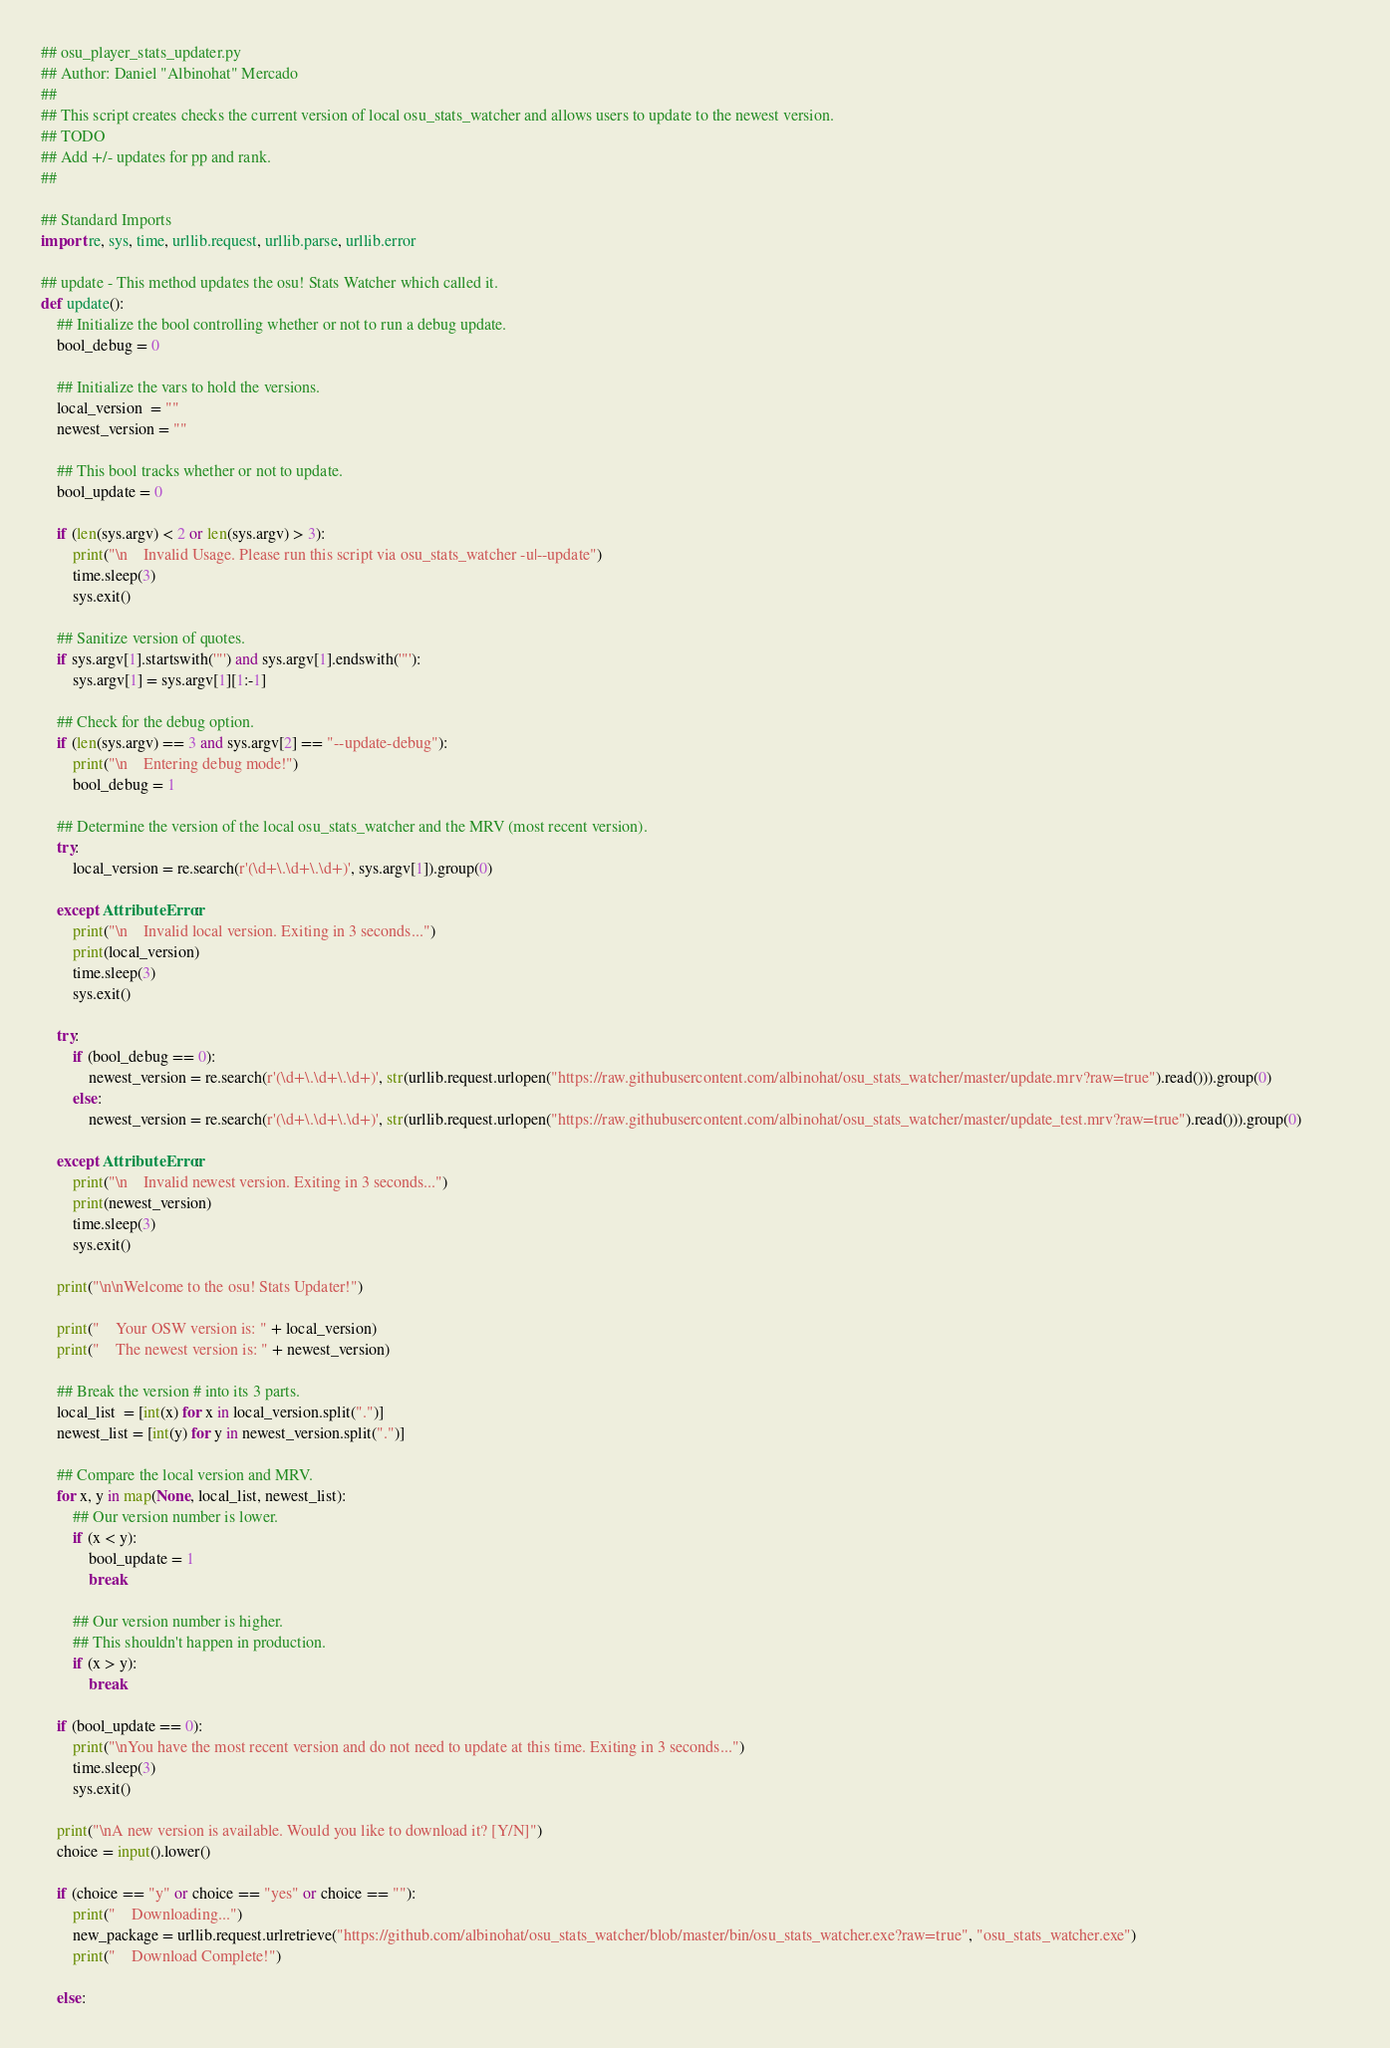<code> <loc_0><loc_0><loc_500><loc_500><_Python_>## osu_player_stats_updater.py
## Author: Daniel "Albinohat" Mercado
## 
## This script creates checks the current version of local osu_stats_watcher and allows users to update to the newest version.
## TODO
## Add +/- updates for pp and rank.
## 

## Standard Imports
import re, sys, time, urllib.request, urllib.parse, urllib.error

## update - This method updates the osu! Stats Watcher which called it.
def update():
	## Initialize the bool controlling whether or not to run a debug update.
	bool_debug = 0

	## Initialize the vars to hold the versions.
	local_version  = ""
	newest_version = ""

	## This bool tracks whether or not to update.
	bool_update = 0

	if (len(sys.argv) < 2 or len(sys.argv) > 3):
		print("\n    Invalid Usage. Please run this script via osu_stats_watcher -u|--update")
		time.sleep(3)
		sys.exit()

	## Sanitize version of quotes.
	if sys.argv[1].startswith('"') and sys.argv[1].endswith('"'):
		sys.argv[1] = sys.argv[1][1:-1]
	
	## Check for the debug option.
	if (len(sys.argv) == 3 and sys.argv[2] == "--update-debug"):
		print("\n    Entering debug mode!")
		bool_debug = 1
	
	## Determine the version of the local osu_stats_watcher and the MRV (most recent version).
	try:
		local_version = re.search(r'(\d+\.\d+\.\d+)', sys.argv[1]).group(0)

	except AttributeError:
		print("\n    Invalid local version. Exiting in 3 seconds...")
		print(local_version)
		time.sleep(3)		
		sys.exit()

	try:
		if (bool_debug == 0):
			newest_version = re.search(r'(\d+\.\d+\.\d+)', str(urllib.request.urlopen("https://raw.githubusercontent.com/albinohat/osu_stats_watcher/master/update.mrv?raw=true").read())).group(0)
		else:
			newest_version = re.search(r'(\d+\.\d+\.\d+)', str(urllib.request.urlopen("https://raw.githubusercontent.com/albinohat/osu_stats_watcher/master/update_test.mrv?raw=true").read())).group(0)			

	except AttributeError:
		print("\n    Invalid newest version. Exiting in 3 seconds...")
		print(newest_version)
		time.sleep(3)		
		sys.exit()
	
	print("\n\nWelcome to the osu! Stats Updater!")

	print("    Your OSW version is: " + local_version)
	print("    The newest version is: " + newest_version)

	## Break the version # into its 3 parts.
	local_list  = [int(x) for x in local_version.split(".")]
	newest_list = [int(y) for y in newest_version.split(".")]

	## Compare the local version and MRV.
	for x, y in map(None, local_list, newest_list):
		## Our version number is lower.
		if (x < y):
			bool_update = 1
			break
		
		## Our version number is higher.
		## This shouldn't happen in production.
		if (x > y):
			break
			
	if (bool_update == 0):
		print("\nYou have the most recent version and do not need to update at this time. Exiting in 3 seconds...")
		time.sleep(3)	
		sys.exit()
		
	print("\nA new version is available. Would you like to download it? [Y/N]")
	choice = input().lower()

	if (choice == "y" or choice == "yes" or choice == ""):
		print("    Downloading...")
		new_package = urllib.request.urlretrieve("https://github.com/albinohat/osu_stats_watcher/blob/master/bin/osu_stats_watcher.exe?raw=true", "osu_stats_watcher.exe")
		print("    Download Complete!")
		
	else:</code> 